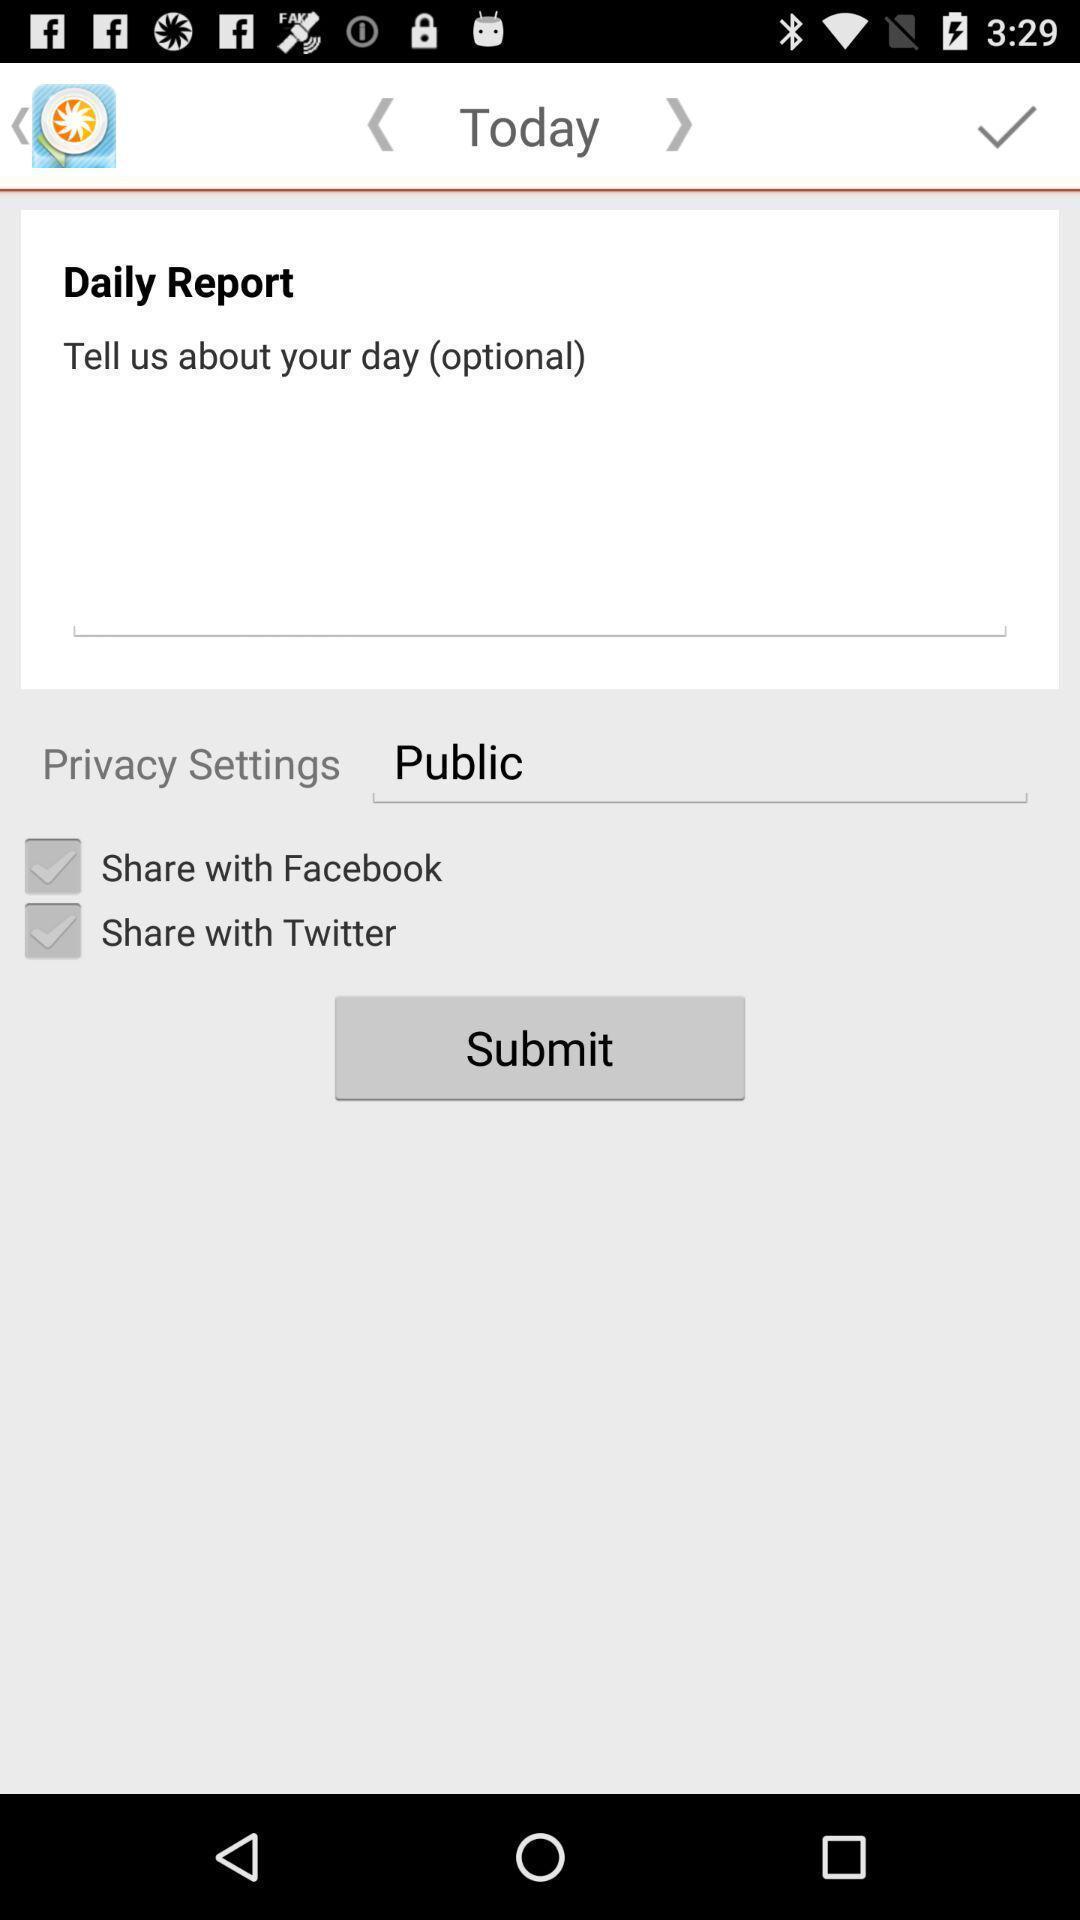Summarize the main components in this picture. Screen displaying multiple share options in report page. 